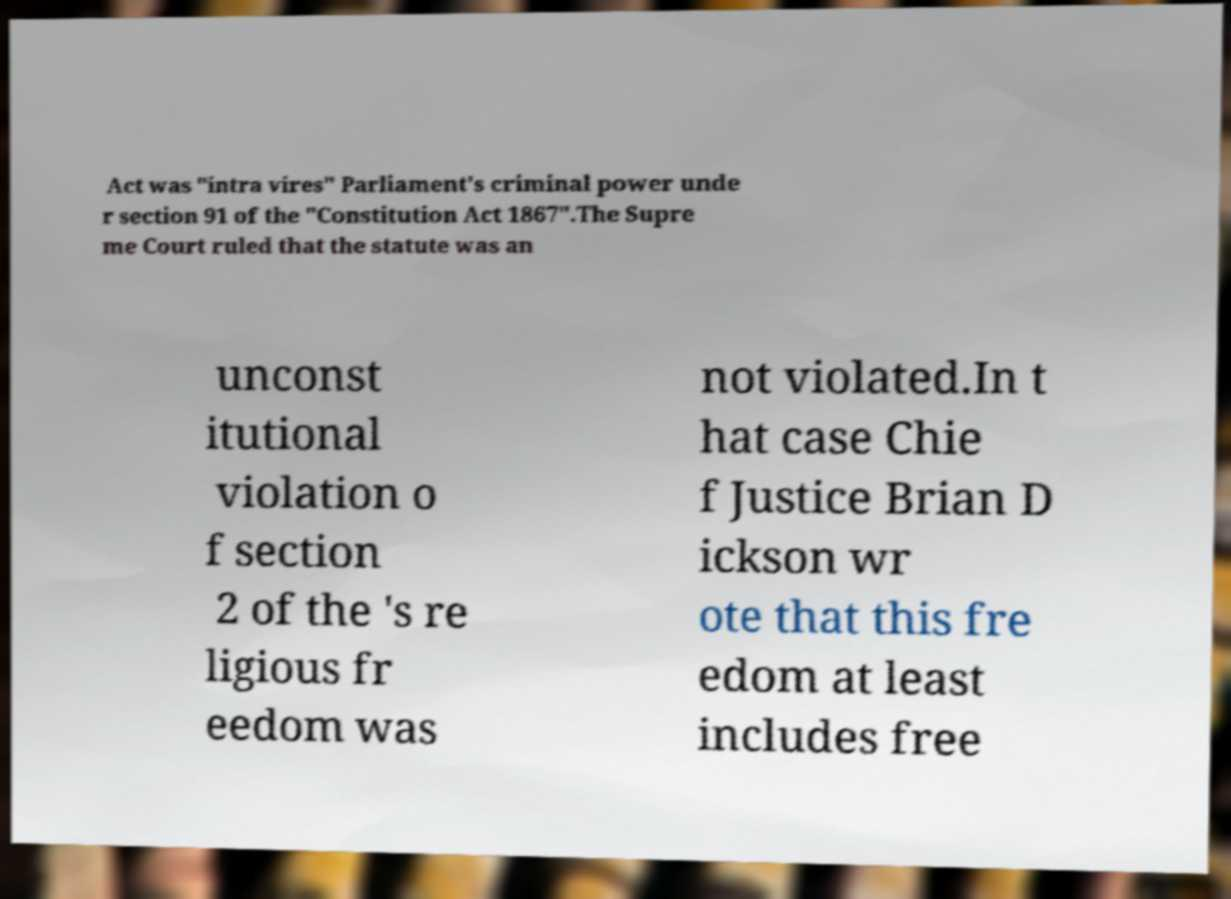There's text embedded in this image that I need extracted. Can you transcribe it verbatim? Act was "intra vires" Parliament's criminal power unde r section 91 of the "Constitution Act 1867".The Supre me Court ruled that the statute was an unconst itutional violation o f section 2 of the 's re ligious fr eedom was not violated.In t hat case Chie f Justice Brian D ickson wr ote that this fre edom at least includes free 